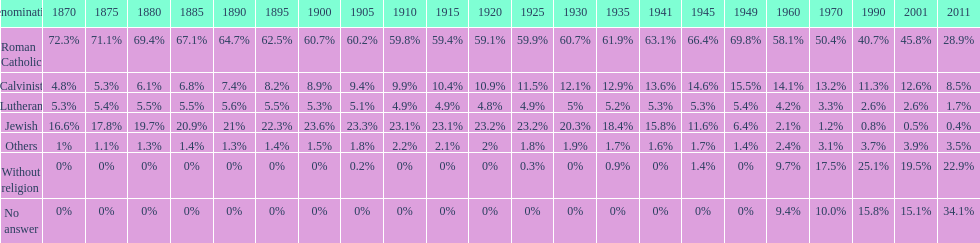The percentage of people who identified as calvinist was, at most, how much? 15.5%. Can you give me this table as a dict? {'header': ['Denomination', '1870', '1875', '1880', '1885', '1890', '1895', '1900', '1905', '1910', '1915', '1920', '1925', '1930', '1935', '1941', '1945', '1949', '1960', '1970', '1990', '2001', '2011'], 'rows': [['Roman Catholic', '72.3%', '71.1%', '69.4%', '67.1%', '64.7%', '62.5%', '60.7%', '60.2%', '59.8%', '59.4%', '59.1%', '59.9%', '60.7%', '61.9%', '63.1%', '66.4%', '69.8%', '58.1%', '50.4%', '40.7%', '45.8%', '28.9%'], ['Calvinist', '4.8%', '5.3%', '6.1%', '6.8%', '7.4%', '8.2%', '8.9%', '9.4%', '9.9%', '10.4%', '10.9%', '11.5%', '12.1%', '12.9%', '13.6%', '14.6%', '15.5%', '14.1%', '13.2%', '11.3%', '12.6%', '8.5%'], ['Lutheran', '5.3%', '5.4%', '5.5%', '5.5%', '5.6%', '5.5%', '5.3%', '5.1%', '4.9%', '4.9%', '4.8%', '4.9%', '5%', '5.2%', '5.3%', '5.3%', '5.4%', '4.2%', '3.3%', '2.6%', '2.6%', '1.7%'], ['Jewish', '16.6%', '17.8%', '19.7%', '20.9%', '21%', '22.3%', '23.6%', '23.3%', '23.1%', '23.1%', '23.2%', '23.2%', '20.3%', '18.4%', '15.8%', '11.6%', '6.4%', '2.1%', '1.2%', '0.8%', '0.5%', '0.4%'], ['Others', '1%', '1.1%', '1.3%', '1.4%', '1.3%', '1.4%', '1.5%', '1.8%', '2.2%', '2.1%', '2%', '1.8%', '1.9%', '1.7%', '1.6%', '1.7%', '1.4%', '2.4%', '3.1%', '3.7%', '3.9%', '3.5%'], ['Without religion', '0%', '0%', '0%', '0%', '0%', '0%', '0%', '0.2%', '0%', '0%', '0%', '0.3%', '0%', '0.9%', '0%', '1.4%', '0%', '9.7%', '17.5%', '25.1%', '19.5%', '22.9%'], ['No answer', '0%', '0%', '0%', '0%', '0%', '0%', '0%', '0%', '0%', '0%', '0%', '0%', '0%', '0%', '0%', '0%', '0%', '9.4%', '10.0%', '15.8%', '15.1%', '34.1%']]} 